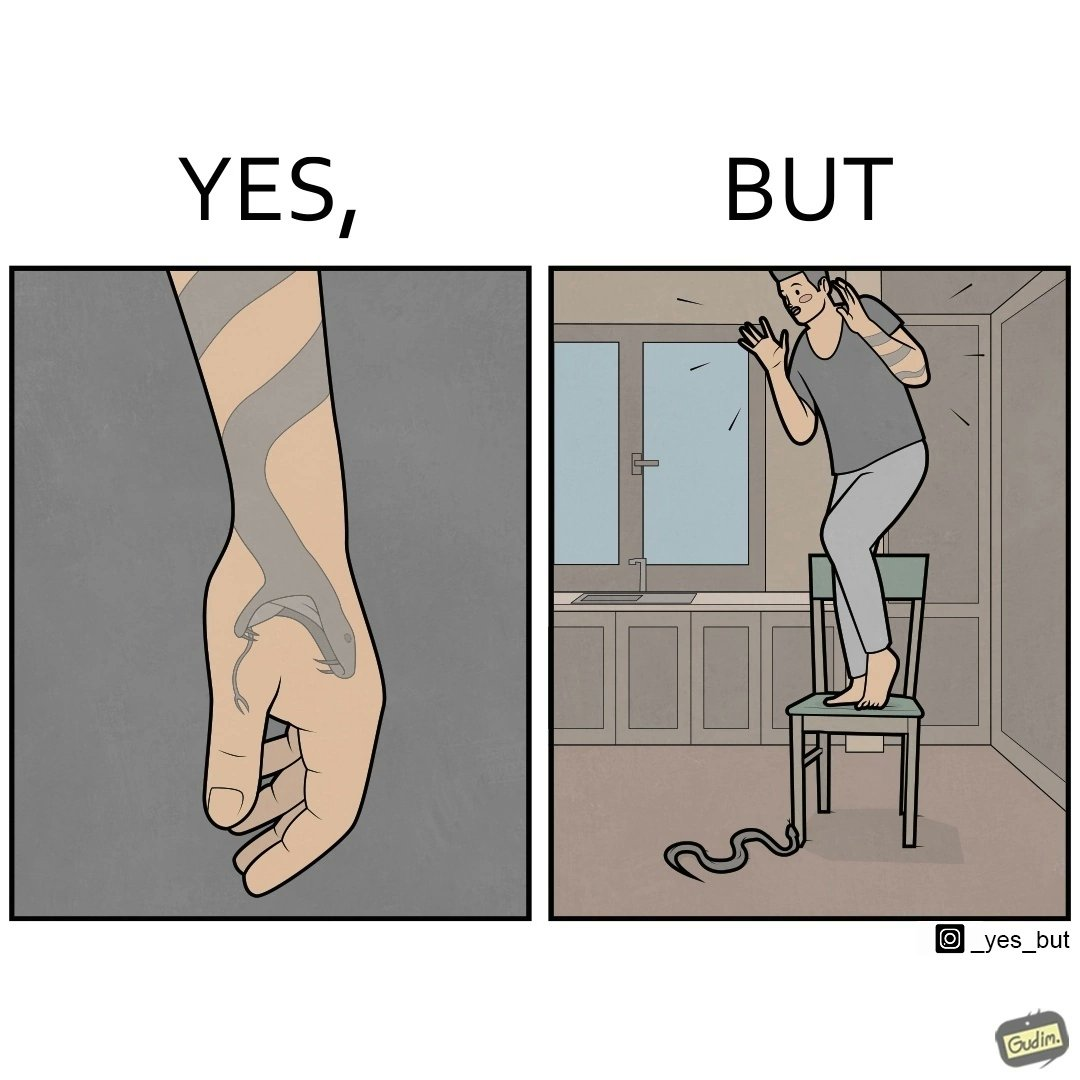Describe what you see in this image. The image is ironic, because in the first image the tattoo of a snake on someone's hand may give us a hint about how powerful or brave the person can be who is having this tattoo but in the second image the person with same tattoo is seen frightened due to a snake in his house 